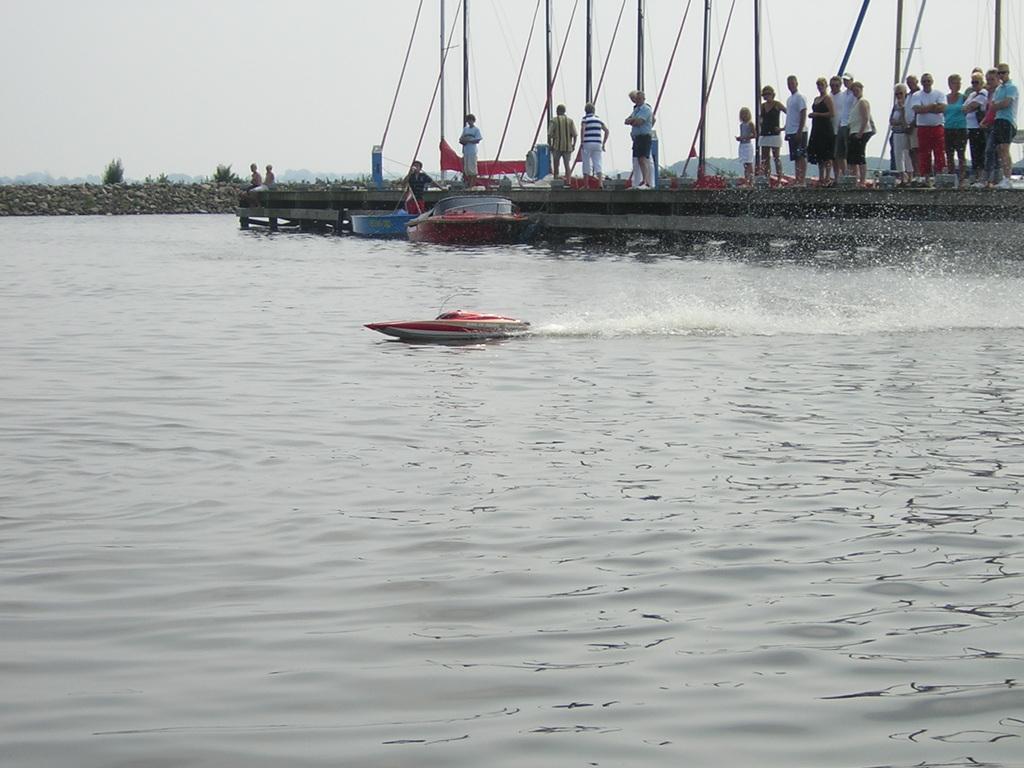How would you summarize this image in a sentence or two? In the middle of the image we can see the rocks, trees, poles, hills and some people are standing on the bridge. In the background of the image we can see the water and boats. At the top of the image we can see the sky. 